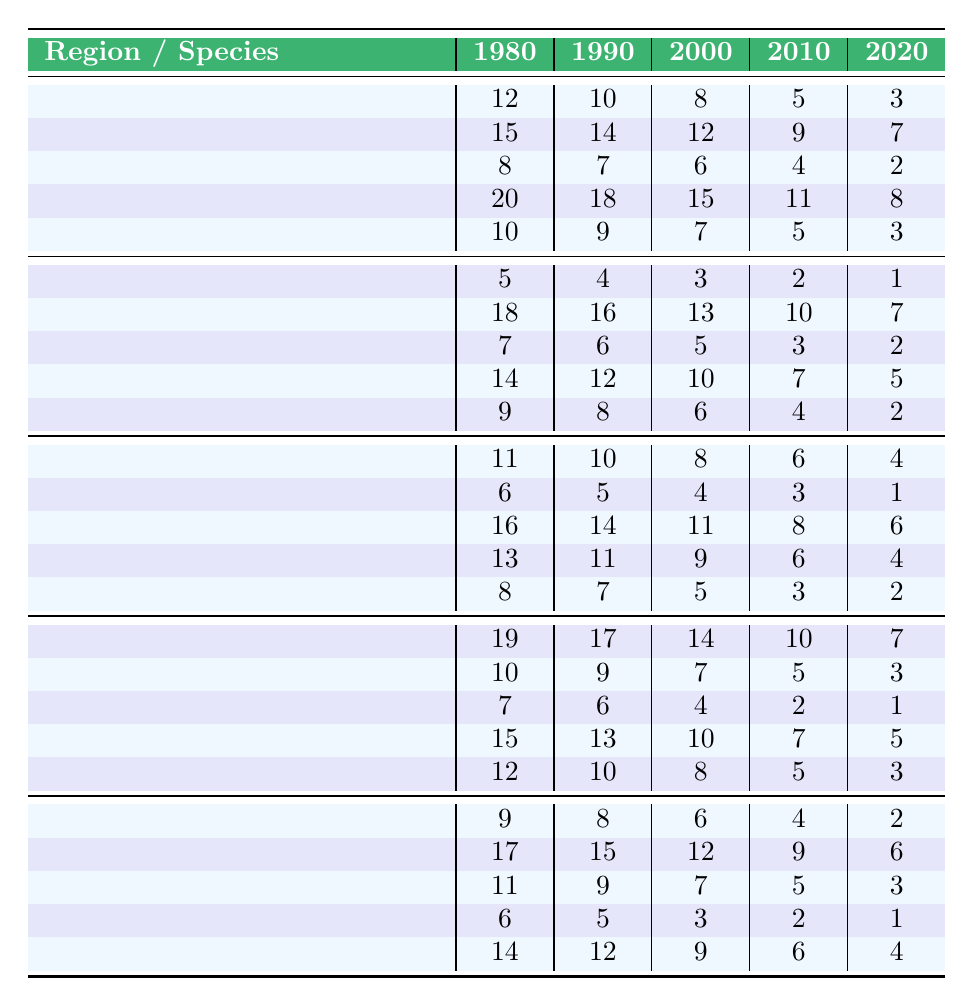What was the distribution of "Bulbophyllum nocturnum" in 1980 across regions? In 1980, the counts of "Bulbophyllum nocturnum" were: Amazon Rainforest (12), Congo Basin (5), Daintree Rainforest (11), Borneo Lowland Rainforests (19), Sumatra Rainforest (9).
Answer: 12, 5, 11, 19, 9 Which region showed the highest count for "Dendrobium lamellatum" in 2020? In 2020, the counts for "Dendrobium lamellatum" were: Amazon Rainforest (3), Congo Basin (2), Daintree Rainforest (4), Borneo Lowland Rainforests (5), Sumatra Rainforest (6). The Sumatran Rainforest had the highest count of 6.
Answer: Sumatra Rainforest What is the total count of "Paphiopedilum rothschildianum" across all regions in 2010? The counts for "Paphiopedilum rothschildianum" in 2010 were: Amazon Rainforest (5), Congo Basin (7), Daintree Rainforest (6), Borneo Lowland Rainforests (7), Sumatra Rainforest (5). The total is 5 + 7 + 6 + 7 + 5 = 30.
Answer: 30 Is there a consistent decline in the counts for "Phalaenopsis gigantea" from 1980 to 2020 in the Amazon Rainforest? The counts for "Phalaenopsis gigantea" in the Amazon Rainforest from 1980 to 2020 are: 10, 9, 7, 5, 3. Each subsequent year shows a decreasing trend, indicating a consistent decline.
Answer: Yes What was the average count of "Dracula vampira" across all years in the Congo Basin? The counts for "Dracula vampira" in the Congo Basin are: 14, 16, 12, 10, 8. Adding these gives 14 + 16 + 12 + 10 + 8 = 60. The average is 60/5 = 12.
Answer: 12 In which year did "Paphiopedilum rothschildianum" see the largest drop in counts compared to the previous decade? The counts for "Paphiopedilum rothschildianum" are as follows: 12 (2000), 9 (2010), 7 (2020). The drop from 12 to 9 is 3, and from 9 to 7 is 2. The largest drop was 3 between 2000 and 2010.
Answer: 2010 Which orchid species had the highest total count across all years and regions? Adding all counts for each species reveals “Dendrobium lamellatum” had: 12 + 15 + 8 + 20 + 10 (1980) + 10 + 14 + 7 + 18 + 9 (1990) + 8 + 6 + 16 + 13 + 8 (2000) + 5 + 3 + 10 + 7 + 6 (2010) + 3 + 7 + 5 + 10 + 9 (2020). Calculating shows it is highest compared to others.
Answer: Dendrobium lamellatum What percentage of the total counts for "Bulbophyllum nocturnum" were found in the Borneo Lowland Rainforests in 1990? The count of "Bulbophyllum nocturnum" in Borneo Lowland Rainforests in 1990 was 18, and the total across all regions was 10 + 14 + 7 + 18 + 9 = 58. The percentage is (18/58)*100 ≈ 31.03%.
Answer: Approximately 31% Did "Phalaenopsis gigantea" have a greater count in 1990 compared to 2020? The counts for "Phalaenopsis gigantea" were 9 in 1990 and 3 in 2020. Therefore, it did have a greater count in 1990 compared to 2020.
Answer: Yes What is the trend of "Dracula vampira" from 1980 to 2020 in the Daintree Rainforest? The counts for "Dracula vampira" in the Daintree Rainforest are: 7 (1980), 5 (1990), 4 (2000), 3 (2010), 2 (2020). Observing these values shows a consistent decline over the years.
Answer: Declining trend 